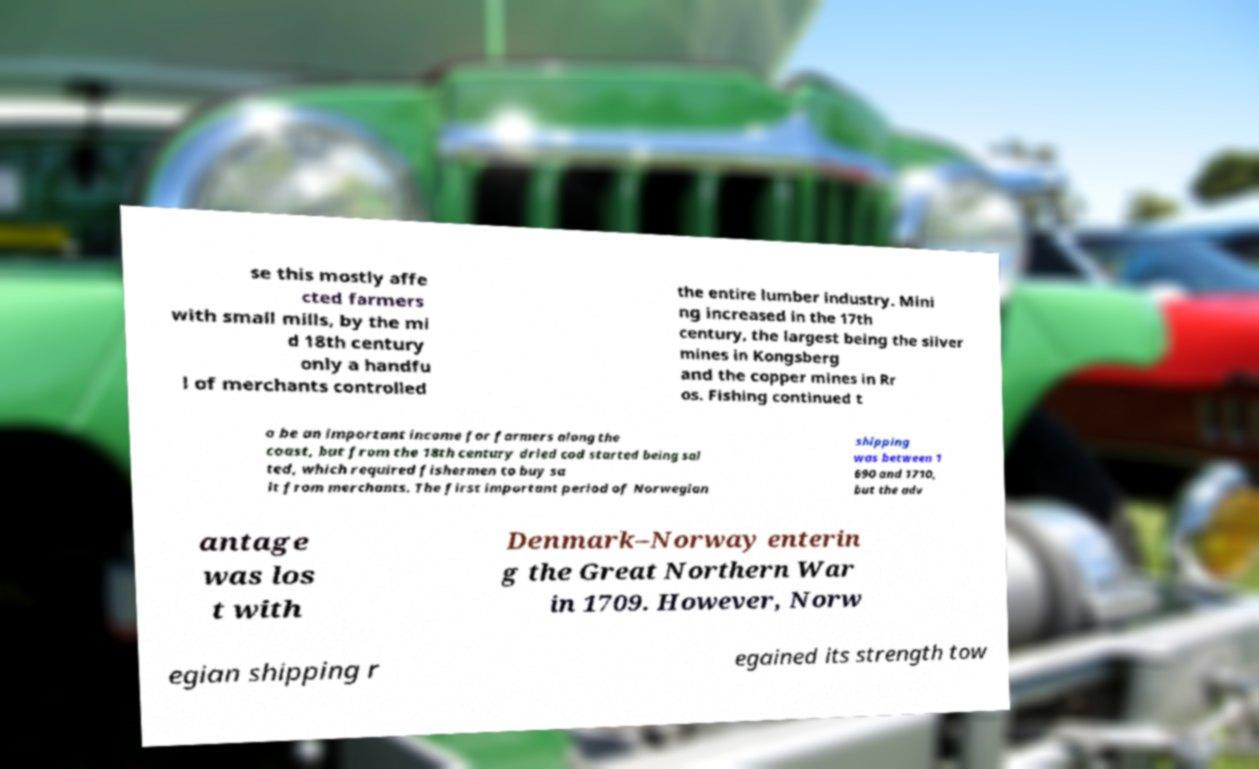Please identify and transcribe the text found in this image. se this mostly affe cted farmers with small mills, by the mi d 18th century only a handfu l of merchants controlled the entire lumber industry. Mini ng increased in the 17th century, the largest being the silver mines in Kongsberg and the copper mines in Rr os. Fishing continued t o be an important income for farmers along the coast, but from the 18th century dried cod started being sal ted, which required fishermen to buy sa lt from merchants. The first important period of Norwegian shipping was between 1 690 and 1710, but the adv antage was los t with Denmark–Norway enterin g the Great Northern War in 1709. However, Norw egian shipping r egained its strength tow 